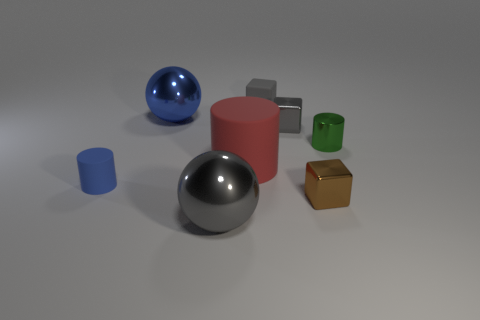There is a gray thing that is the same size as the gray metallic block; what is its shape?
Provide a succinct answer. Cube. What number of objects are blue metal blocks or tiny cylinders right of the red matte object?
Ensure brevity in your answer.  1. Is the material of the object in front of the small brown thing the same as the big object that is behind the large red cylinder?
Your answer should be compact. Yes. There is a big metallic object that is the same color as the tiny rubber cube; what is its shape?
Your response must be concise. Sphere. How many green things are either large cylinders or big metal objects?
Your answer should be very brief. 0. What size is the brown block?
Offer a very short reply. Small. Is the number of large gray metallic balls that are behind the small blue rubber object greater than the number of blue objects?
Make the answer very short. No. There is a gray metal cube; what number of small metal cylinders are to the right of it?
Give a very brief answer. 1. Is there a blue metallic sphere of the same size as the red cylinder?
Give a very brief answer. Yes. The other metal thing that is the same shape as the brown object is what color?
Make the answer very short. Gray. 